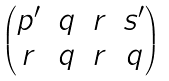Convert formula to latex. <formula><loc_0><loc_0><loc_500><loc_500>\begin{pmatrix} p ^ { \prime } & q & r & s ^ { \prime } \\ r & q & r & q \end{pmatrix}</formula> 